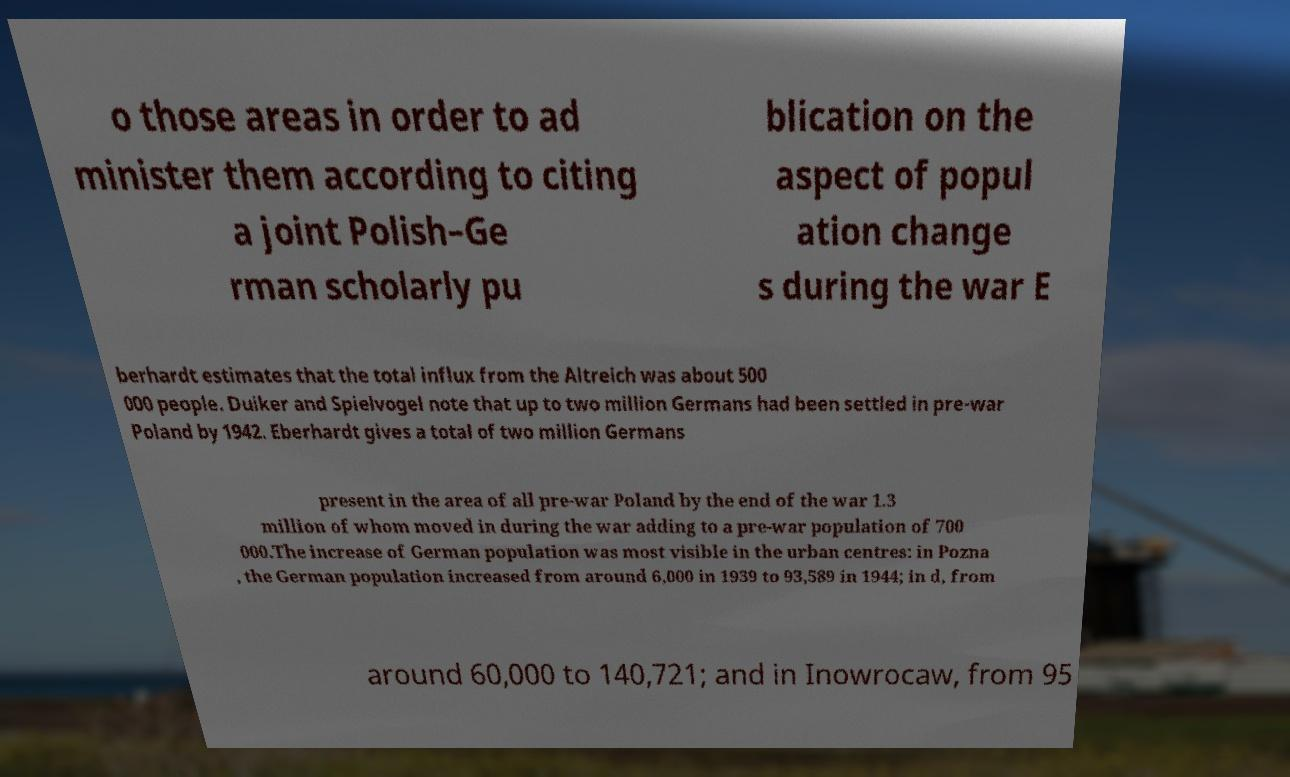I need the written content from this picture converted into text. Can you do that? o those areas in order to ad minister them according to citing a joint Polish–Ge rman scholarly pu blication on the aspect of popul ation change s during the war E berhardt estimates that the total influx from the Altreich was about 500 000 people. Duiker and Spielvogel note that up to two million Germans had been settled in pre-war Poland by 1942. Eberhardt gives a total of two million Germans present in the area of all pre-war Poland by the end of the war 1.3 million of whom moved in during the war adding to a pre-war population of 700 000.The increase of German population was most visible in the urban centres: in Pozna , the German population increased from around 6,000 in 1939 to 93,589 in 1944; in d, from around 60,000 to 140,721; and in Inowrocaw, from 95 